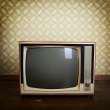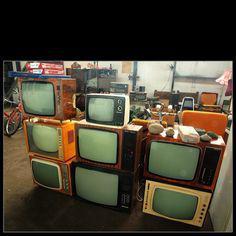The first image is the image on the left, the second image is the image on the right. Given the left and right images, does the statement "There is no more than one television in the left image." hold true? Answer yes or no. Yes. The first image is the image on the left, the second image is the image on the right. Considering the images on both sides, is "There is one tube type television in the image on the left." valid? Answer yes or no. Yes. 